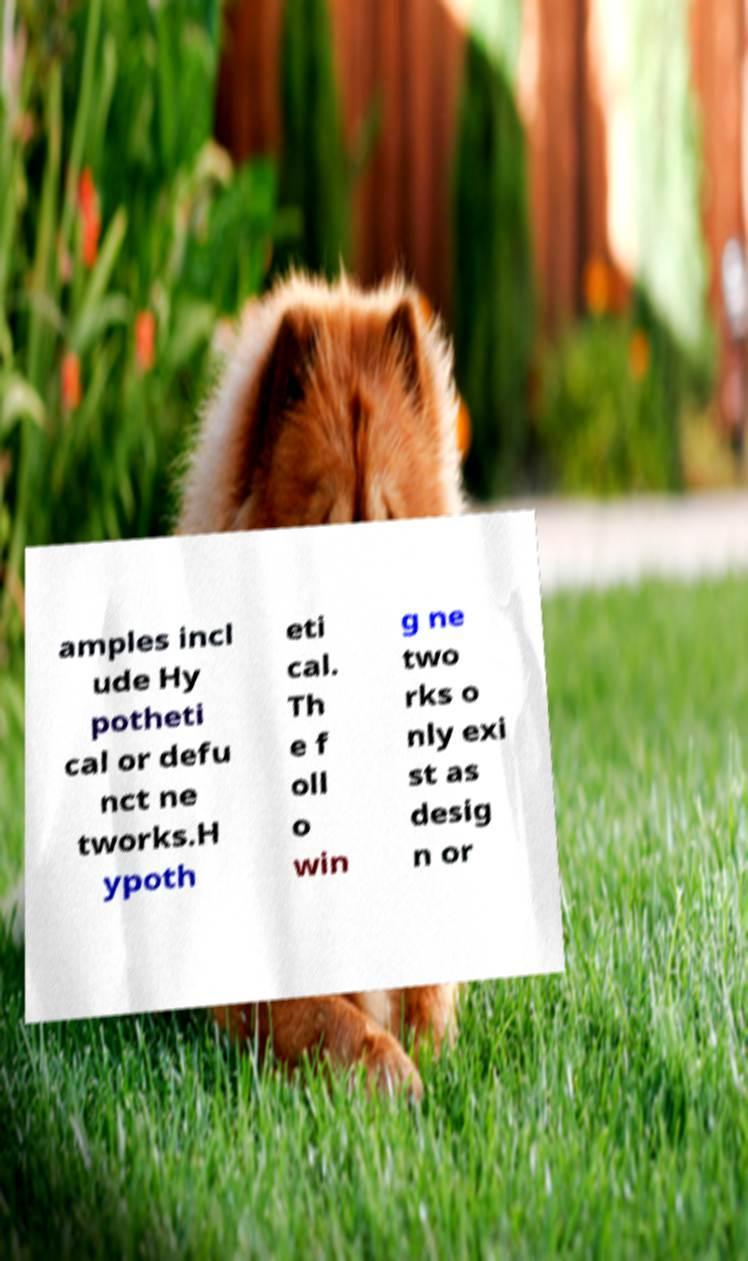Please read and relay the text visible in this image. What does it say? amples incl ude Hy potheti cal or defu nct ne tworks.H ypoth eti cal. Th e f oll o win g ne two rks o nly exi st as desig n or 